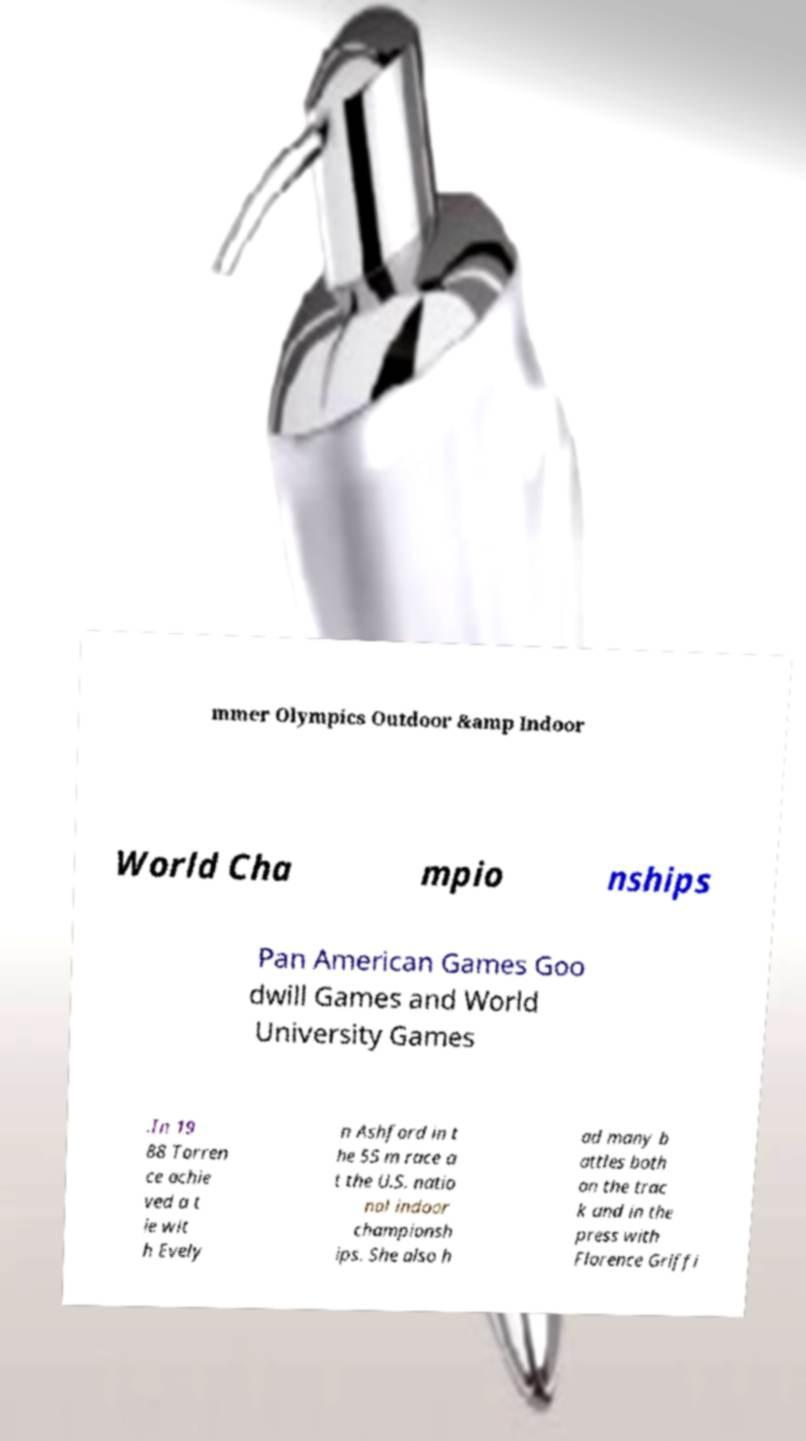Please identify and transcribe the text found in this image. mmer Olympics Outdoor &amp Indoor World Cha mpio nships Pan American Games Goo dwill Games and World University Games .In 19 88 Torren ce achie ved a t ie wit h Evely n Ashford in t he 55 m race a t the U.S. natio nal indoor championsh ips. She also h ad many b attles both on the trac k and in the press with Florence Griffi 